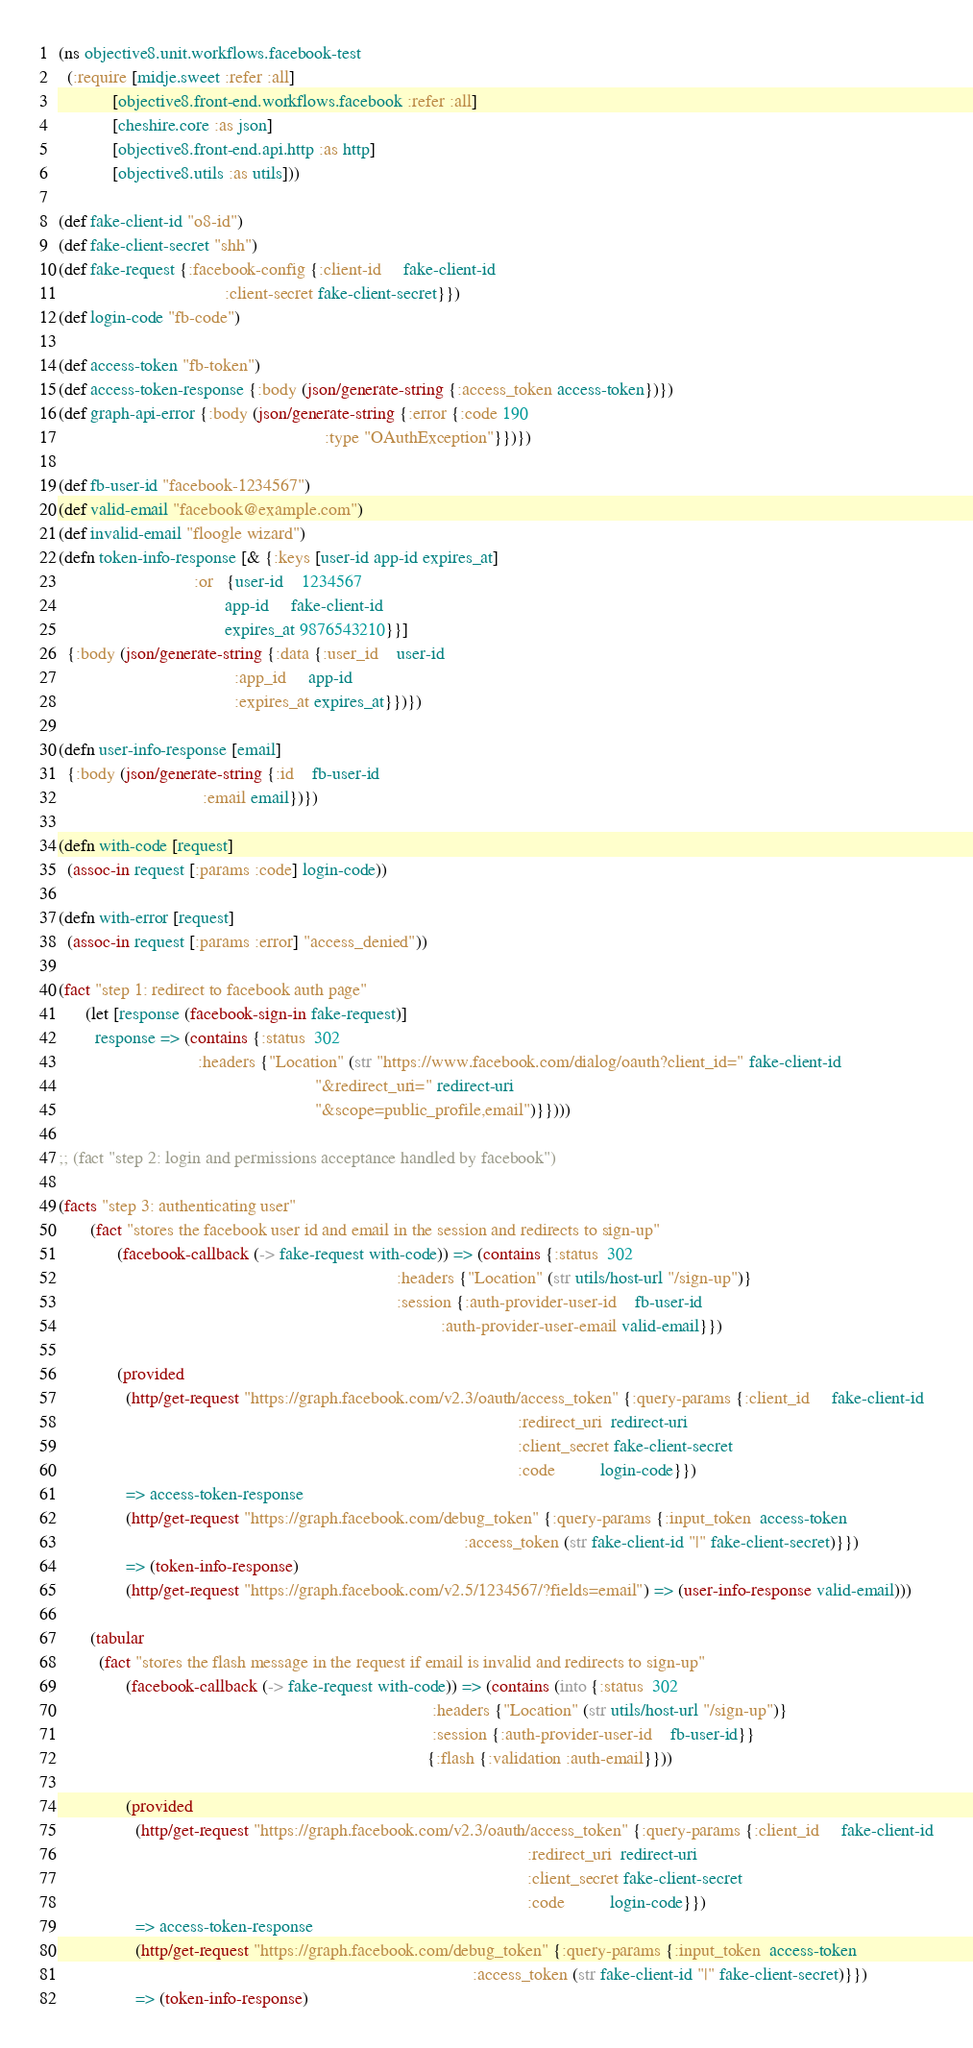<code> <loc_0><loc_0><loc_500><loc_500><_Clojure_>(ns objective8.unit.workflows.facebook-test
  (:require [midje.sweet :refer :all]
            [objective8.front-end.workflows.facebook :refer :all]
            [cheshire.core :as json]
            [objective8.front-end.api.http :as http]
            [objective8.utils :as utils]))

(def fake-client-id "o8-id")
(def fake-client-secret "shh")
(def fake-request {:facebook-config {:client-id     fake-client-id
                                     :client-secret fake-client-secret}})
(def login-code "fb-code")

(def access-token "fb-token")
(def access-token-response {:body (json/generate-string {:access_token access-token})})
(def graph-api-error {:body (json/generate-string {:error {:code 190
                                                           :type "OAuthException"}})})

(def fb-user-id "facebook-1234567")
(def valid-email "facebook@example.com")
(def invalid-email "floogle wizard")
(defn token-info-response [& {:keys [user-id app-id expires_at]
                              :or   {user-id    1234567
                                     app-id     fake-client-id
                                     expires_at 9876543210}}]
  {:body (json/generate-string {:data {:user_id    user-id
                                       :app_id     app-id
                                       :expires_at expires_at}})})

(defn user-info-response [email]
  {:body (json/generate-string {:id    fb-user-id
                                :email email})})

(defn with-code [request]
  (assoc-in request [:params :code] login-code))

(defn with-error [request]
  (assoc-in request [:params :error] "access_denied"))

(fact "step 1: redirect to facebook auth page"
      (let [response (facebook-sign-in fake-request)]
        response => (contains {:status  302
                               :headers {"Location" (str "https://www.facebook.com/dialog/oauth?client_id=" fake-client-id
                                                         "&redirect_uri=" redirect-uri
                                                         "&scope=public_profile,email")}})))

;; (fact "step 2: login and permissions acceptance handled by facebook")

(facts "step 3: authenticating user"
       (fact "stores the facebook user id and email in the session and redirects to sign-up"
             (facebook-callback (-> fake-request with-code)) => (contains {:status  302
                                                                           :headers {"Location" (str utils/host-url "/sign-up")}
                                                                           :session {:auth-provider-user-id    fb-user-id
                                                                                     :auth-provider-user-email valid-email}})

             (provided
               (http/get-request "https://graph.facebook.com/v2.3/oauth/access_token" {:query-params {:client_id     fake-client-id
                                                                                                      :redirect_uri  redirect-uri
                                                                                                      :client_secret fake-client-secret
                                                                                                      :code          login-code}})
               => access-token-response
               (http/get-request "https://graph.facebook.com/debug_token" {:query-params {:input_token  access-token
                                                                                          :access_token (str fake-client-id "|" fake-client-secret)}})
               => (token-info-response)
               (http/get-request "https://graph.facebook.com/v2.5/1234567/?fields=email") => (user-info-response valid-email)))

       (tabular
         (fact "stores the flash message in the request if email is invalid and redirects to sign-up"
               (facebook-callback (-> fake-request with-code)) => (contains (into {:status  302
                                                                                   :headers {"Location" (str utils/host-url "/sign-up")}
                                                                                   :session {:auth-provider-user-id    fb-user-id}}
                                                                                  {:flash {:validation :auth-email}}))

               (provided
                 (http/get-request "https://graph.facebook.com/v2.3/oauth/access_token" {:query-params {:client_id     fake-client-id
                                                                                                        :redirect_uri  redirect-uri
                                                                                                        :client_secret fake-client-secret
                                                                                                        :code          login-code}})
                 => access-token-response
                 (http/get-request "https://graph.facebook.com/debug_token" {:query-params {:input_token  access-token
                                                                                            :access_token (str fake-client-id "|" fake-client-secret)}})
                 => (token-info-response)</code> 